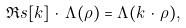Convert formula to latex. <formula><loc_0><loc_0><loc_500><loc_500>\Re s { [ k ] } \, \cdot \, \Lambda ( \rho ) = \Lambda ( k \, \cdot \, \rho ) ,</formula> 